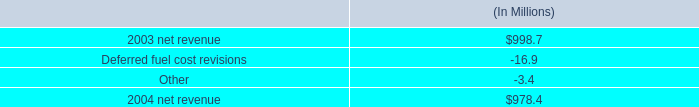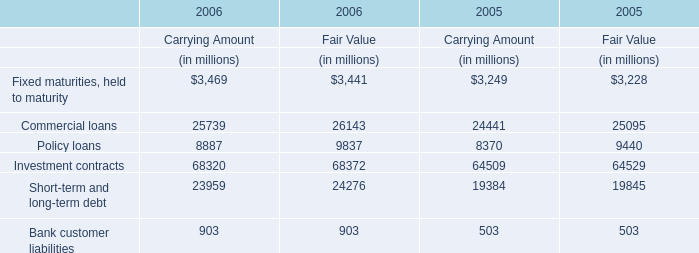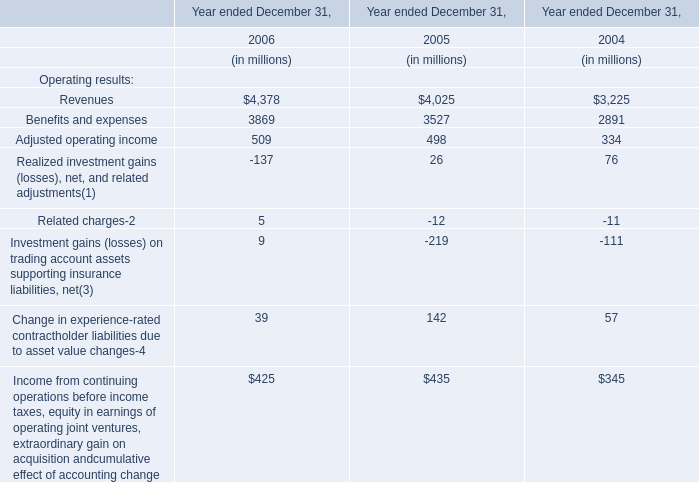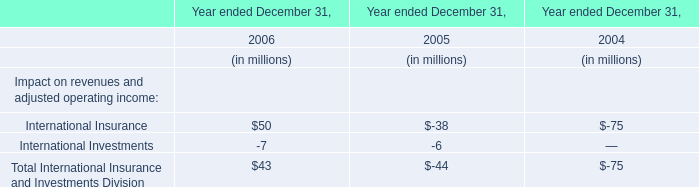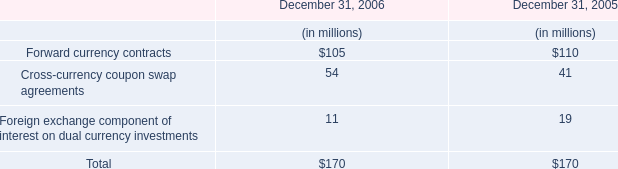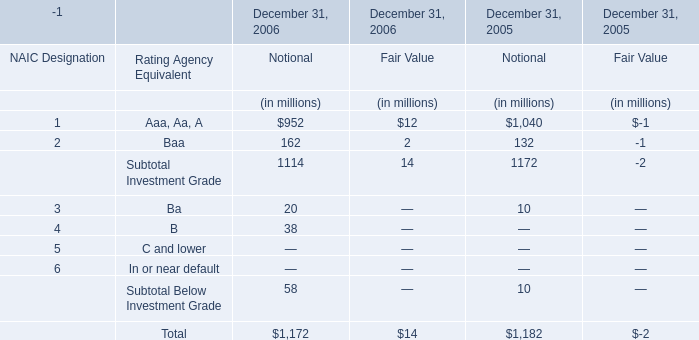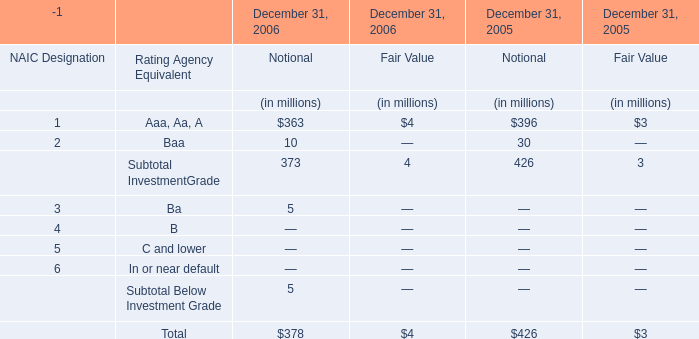What was the average value of the Subtotal InvestmentGrade for Notional in the years where Aaa, Aa, A for Notional is positive? (in million) 
Computations: ((373 + 426) / 2)
Answer: 399.5. 